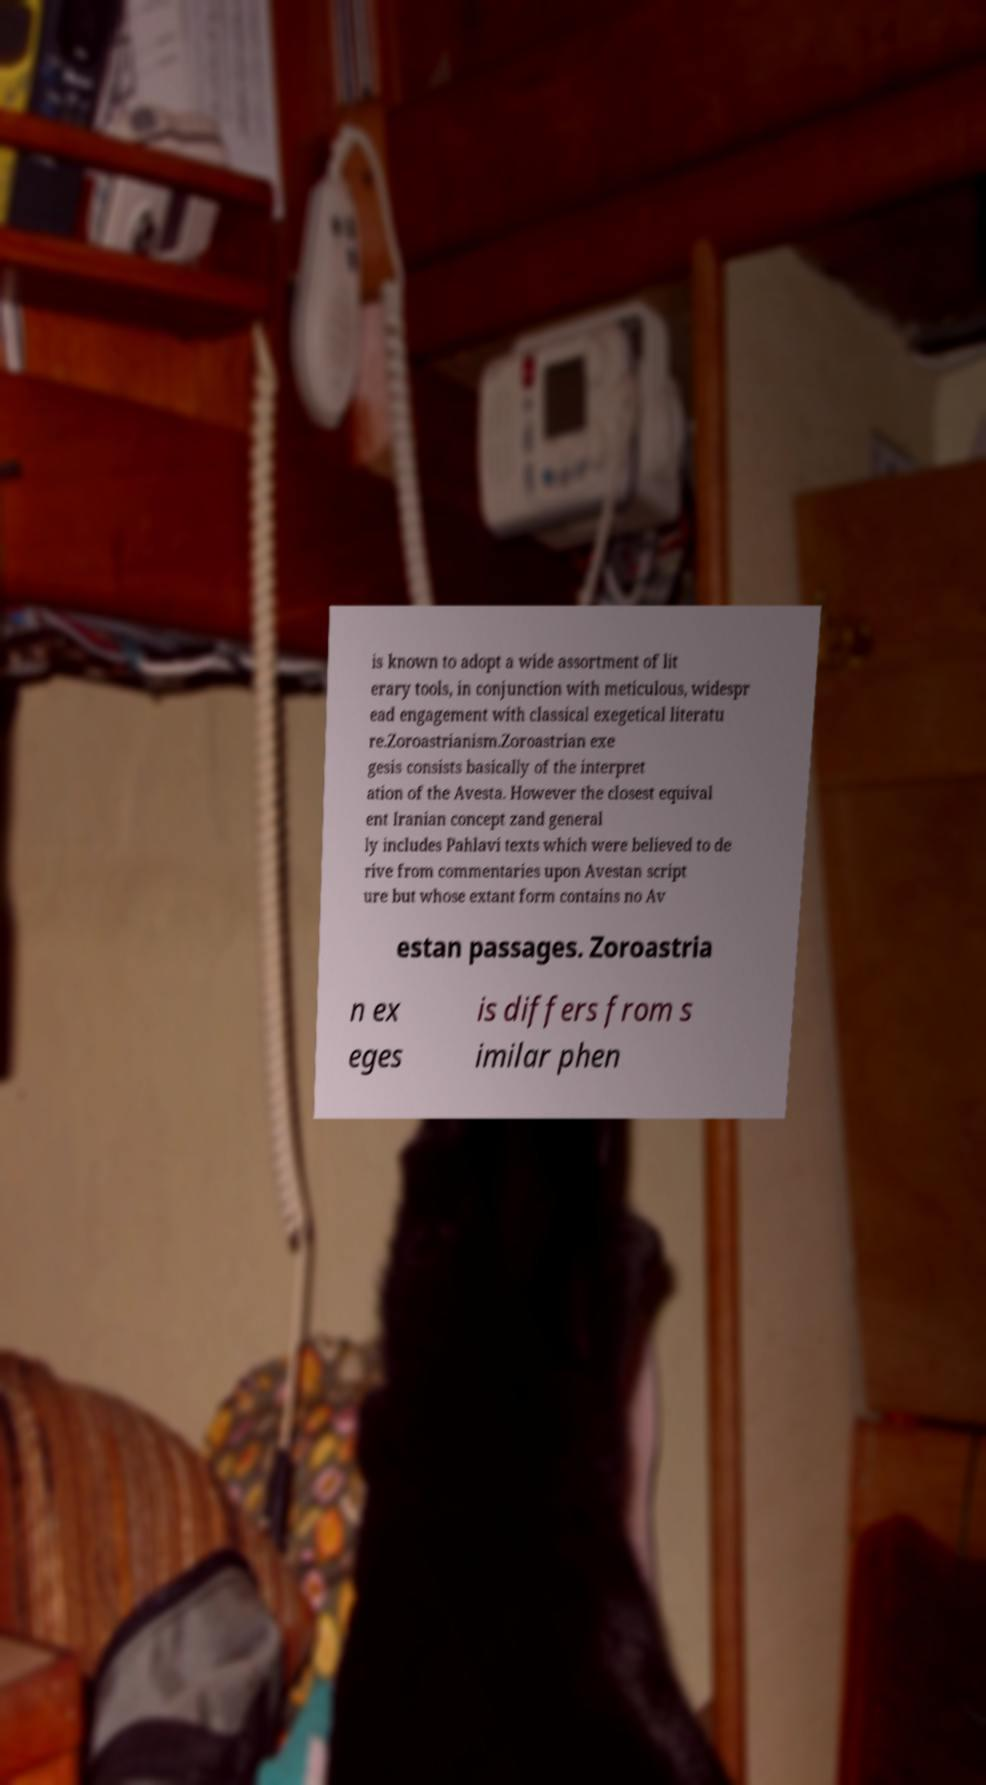There's text embedded in this image that I need extracted. Can you transcribe it verbatim? is known to adopt a wide assortment of lit erary tools, in conjunction with meticulous, widespr ead engagement with classical exegetical literatu re.Zoroastrianism.Zoroastrian exe gesis consists basically of the interpret ation of the Avesta. However the closest equival ent Iranian concept zand general ly includes Pahlavi texts which were believed to de rive from commentaries upon Avestan script ure but whose extant form contains no Av estan passages. Zoroastria n ex eges is differs from s imilar phen 